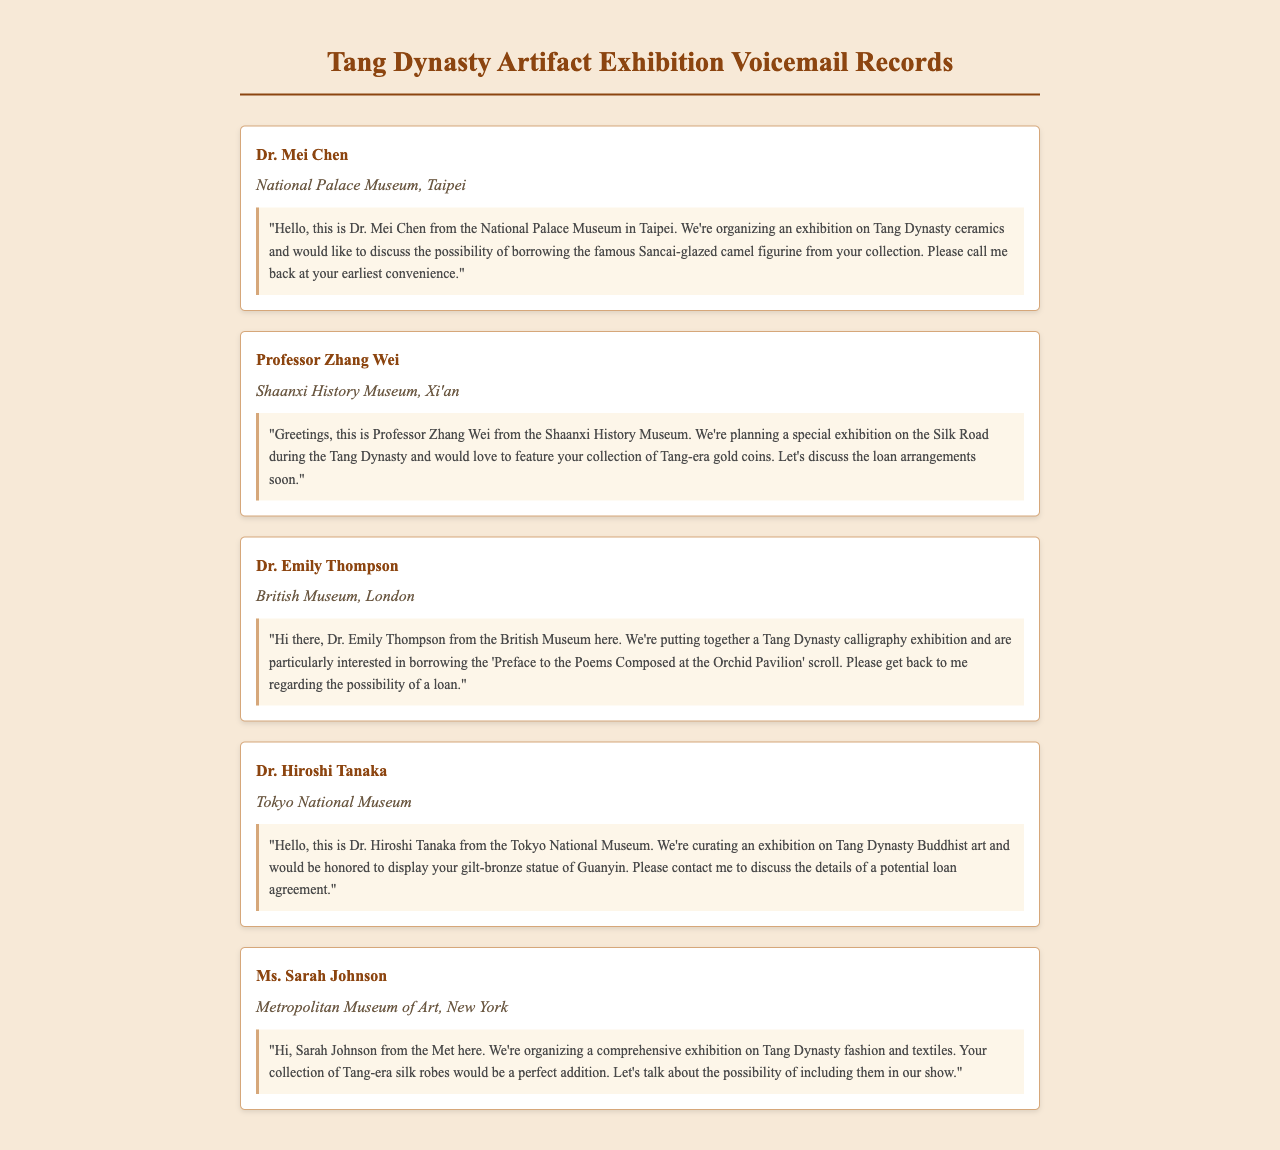What is the name of the curator from the National Palace Museum? The document states that Dr. Mei Chen is the curator from the National Palace Museum.
Answer: Dr. Mei Chen Which type of artifact is the focus of the exhibition by the National Palace Museum? Dr. Mei Chen mentioned organizing an exhibition on ceramics from the Tang Dynasty.
Answer: Ceramics What loan item is Professor Zhang Wei interested in? According to Professor Zhang Wei’s message, he wants to feature Tang-era gold coins in his exhibition.
Answer: Tang-era gold coins How many curators are mentioned in the document? The document lists five curators and their respective institutions.
Answer: Five Which museum is Dr. Emily Thompson associated with? The voicemail indicates that Dr. Emily Thompson is from the British Museum.
Answer: British Museum What exhibition theme is Dr. Hiroshi Tanaka curating? Dr. Hiroshi Tanaka is curating an exhibition on Tang Dynasty Buddhist art.
Answer: Buddhist art What is the main topic of the exhibition organized by the Metropolitan Museum of Art? Ms. Sarah Johnson is organizing an exhibition on Tang Dynasty fashion and textiles.
Answer: Fashion and textiles Which artifact is Dr. Hiroshi Tanaka interested in borrowing? Dr. Hiroshi Tanaka is interested in displaying the gilt-bronze statue of Guanyin.
Answer: Gilt-bronze statue of Guanyin What city is the Shaanxi History Museum located in? The document specifies that the Shaanxi History Museum is located in Xi'an.
Answer: Xi'an 